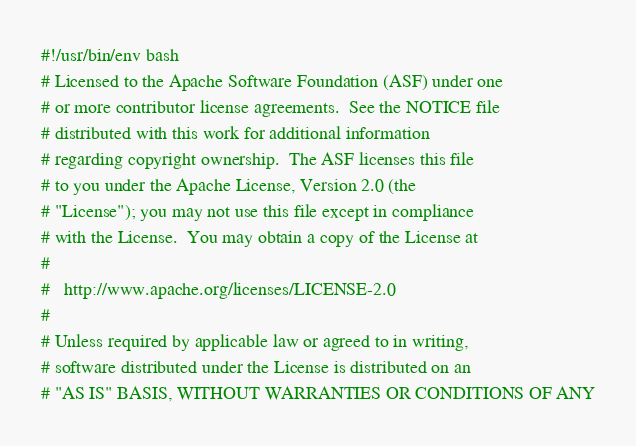Convert code to text. <code><loc_0><loc_0><loc_500><loc_500><_Bash_>#!/usr/bin/env bash
# Licensed to the Apache Software Foundation (ASF) under one
# or more contributor license agreements.  See the NOTICE file
# distributed with this work for additional information
# regarding copyright ownership.  The ASF licenses this file
# to you under the Apache License, Version 2.0 (the
# "License"); you may not use this file except in compliance
# with the License.  You may obtain a copy of the License at
#
#   http://www.apache.org/licenses/LICENSE-2.0
#
# Unless required by applicable law or agreed to in writing,
# software distributed under the License is distributed on an
# "AS IS" BASIS, WITHOUT WARRANTIES OR CONDITIONS OF ANY</code> 